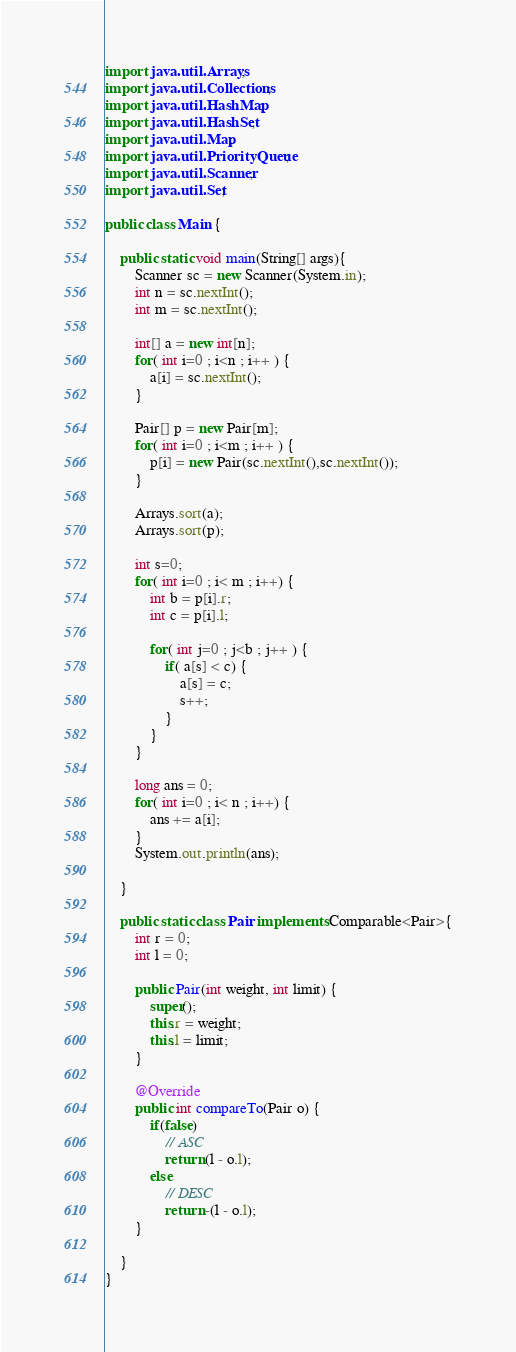Convert code to text. <code><loc_0><loc_0><loc_500><loc_500><_Java_>import java.util.Arrays;
import java.util.Collections;
import java.util.HashMap;
import java.util.HashSet;
import java.util.Map;
import java.util.PriorityQueue;
import java.util.Scanner;
import java.util.Set;

public class Main {

	public static void main(String[] args){
		Scanner sc = new Scanner(System.in);
		int n = sc.nextInt();
		int m = sc.nextInt();

		int[] a = new int[n];
		for( int i=0 ; i<n ; i++ ) {
			a[i] = sc.nextInt();
		}

		Pair[] p = new Pair[m];
		for( int i=0 ; i<m ; i++ ) {
			p[i] = new Pair(sc.nextInt(),sc.nextInt());
		}

		Arrays.sort(a);
		Arrays.sort(p);

		int s=0;
		for( int i=0 ; i< m ; i++) {
			int b = p[i].r;
			int c = p[i].l;
			
			for( int j=0 ; j<b ; j++ ) {
				if( a[s] < c) {
					a[s] = c;
					s++;
				}
			}
		}
		
		long ans = 0;
		for( int i=0 ; i< n ; i++) {
			ans += a[i];
		}
		System.out.println(ans);
		
	}

	public static class Pair implements Comparable<Pair>{
		int r = 0;
		int l = 0;
		
		public Pair(int weight, int limit) {
			super();
			this.r = weight;
			this.l = limit;
		}

		@Override
		public int compareTo(Pair o) {
			if(false)
				// ASC
				return (l - o.l);
			else
				// DESC
				return -(l - o.l);
		}
	
	}
}</code> 